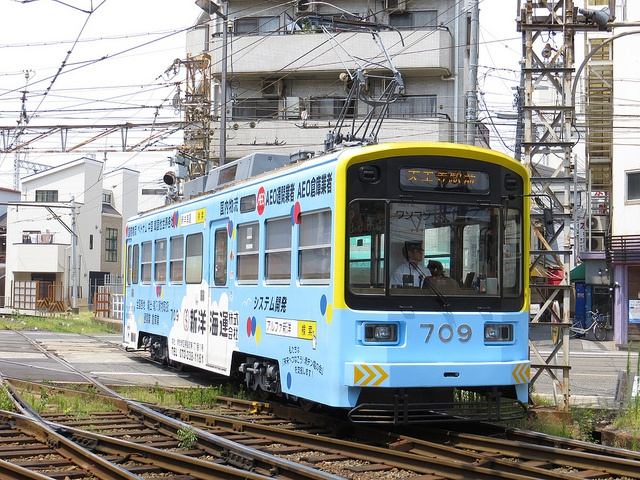Describe the objects in this image and their specific colors. I can see train in white, black, lightblue, and gray tones and people in white, black, and gray tones in this image. 